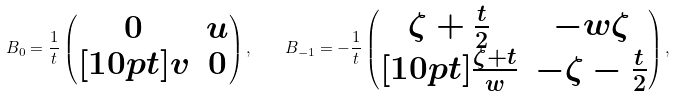Convert formula to latex. <formula><loc_0><loc_0><loc_500><loc_500>B _ { 0 } = \frac { 1 } { t } \begin{pmatrix} 0 & u \\ [ 1 0 p t ] v & 0 \end{pmatrix} , \quad B _ { - 1 } = - \frac { 1 } { t } \begin{pmatrix} \zeta + \frac { t } { 2 } & - w \zeta \\ [ 1 0 p t ] \frac { \zeta + t } { w } & - \zeta - \frac { t } { 2 } \end{pmatrix} ,</formula> 